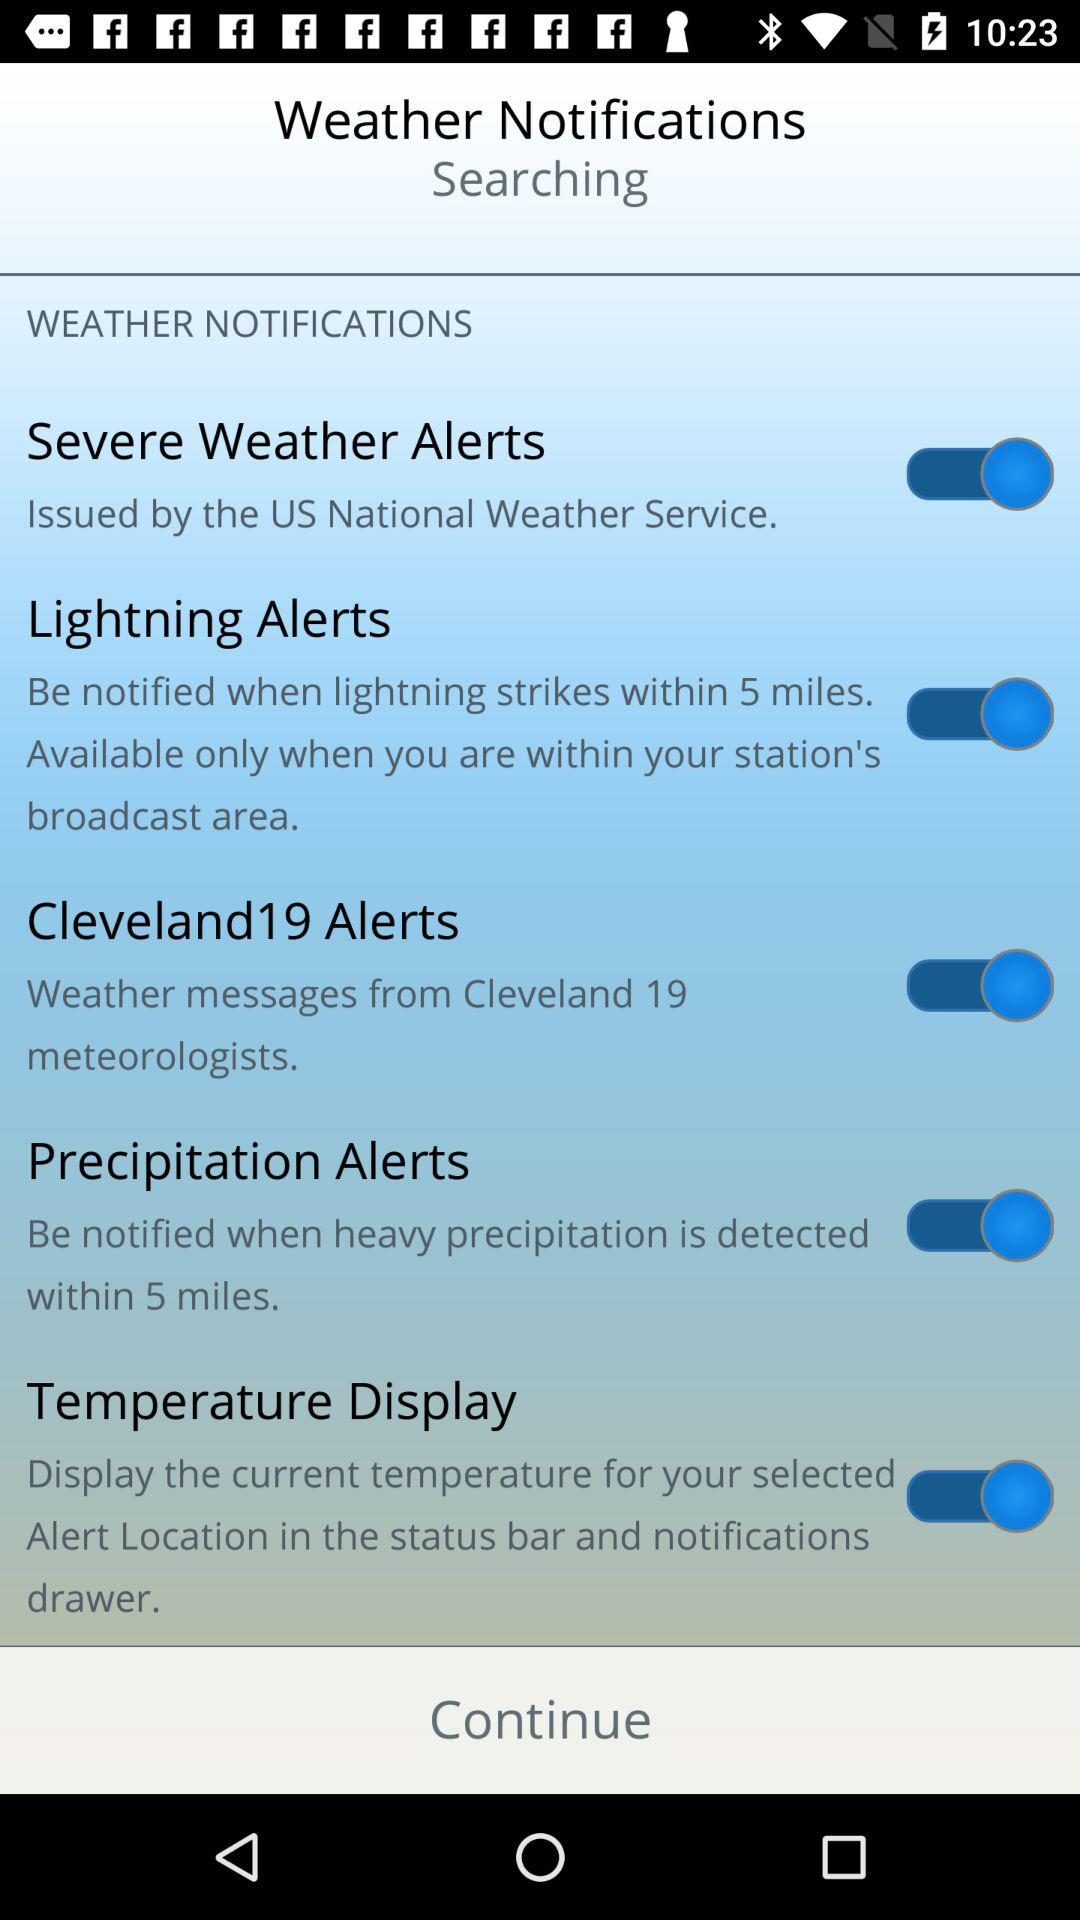What is the status of the "Severe Weather Alerts"? The status of the "Severe Weather Alerts" is "on". 